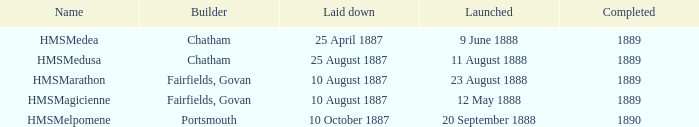Which builder completed before 1890 and launched on 9 june 1888? Chatham. 